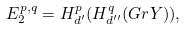<formula> <loc_0><loc_0><loc_500><loc_500>E _ { 2 } ^ { p , q } = H ^ { p } _ { d ^ { \prime } } ( H ^ { q } _ { d ^ { \prime \prime } } ( G r Y ) ) ,</formula> 